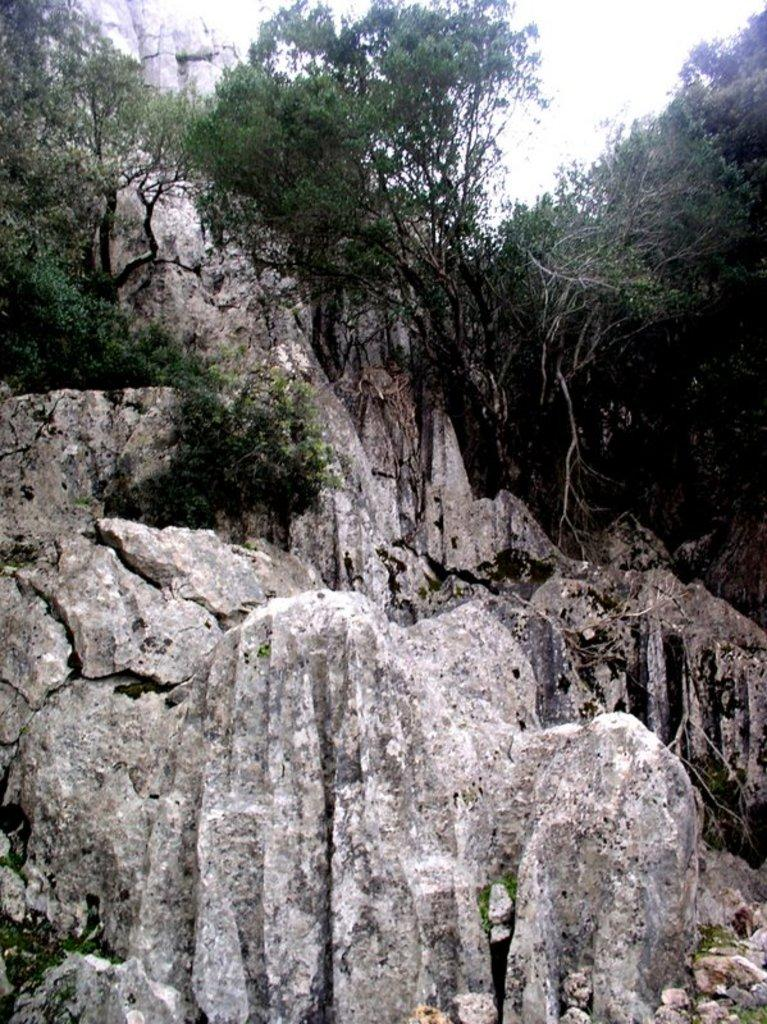What type of natural formation can be seen in the image? There are mountains in the image. What other natural elements are present in the image? Trees and stones are visible in the image. What is visible at the top of the image? The sky is visible at the top of the image. What type of health advice can be seen in the image? There is no health advice present in the image; it features mountains, trees, stones, and the sky. What color is the skirt worn by the person in the image? There is no person wearing a skirt present in the image. 